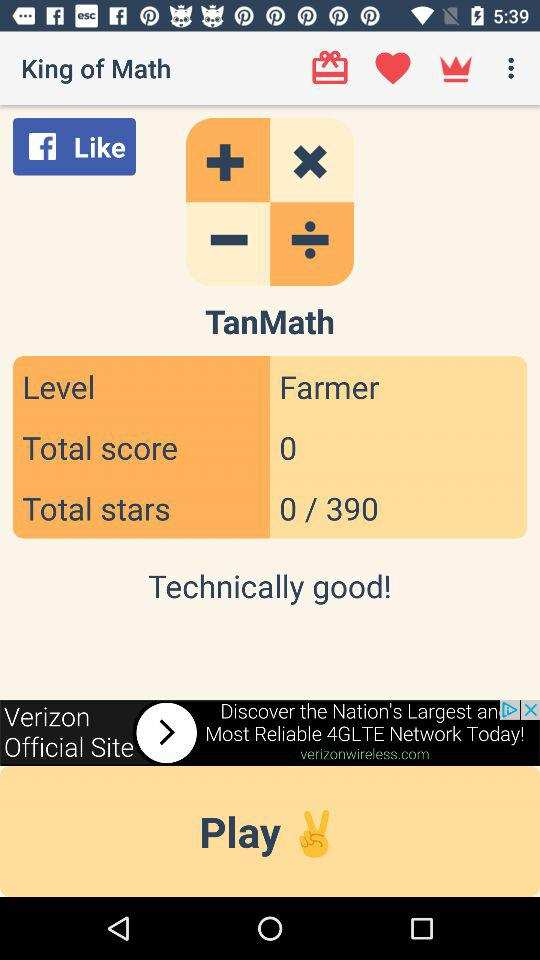What is the app name? The app name is "King of Math". 